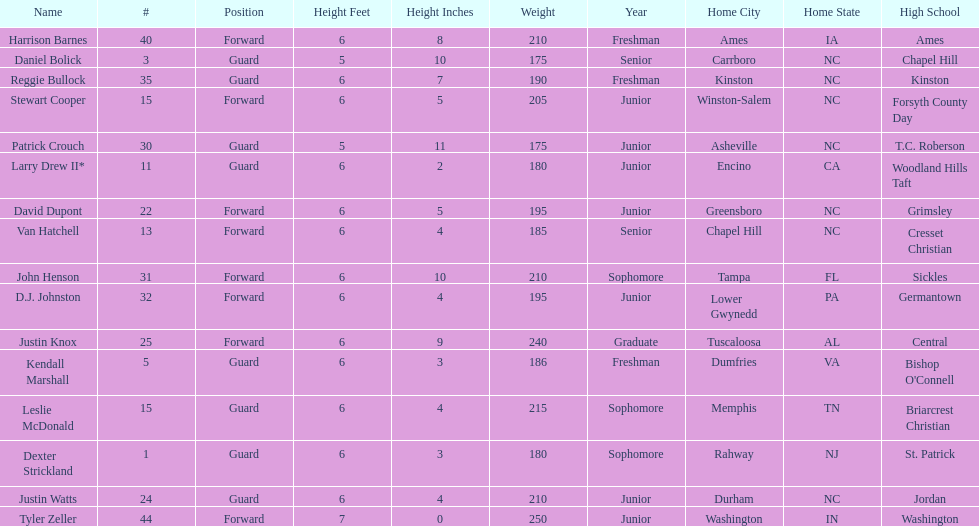Names of players who were exactly 6 feet, 4 inches tall, but did not weight over 200 pounds Van Hatchell, D.J. Johnston. 